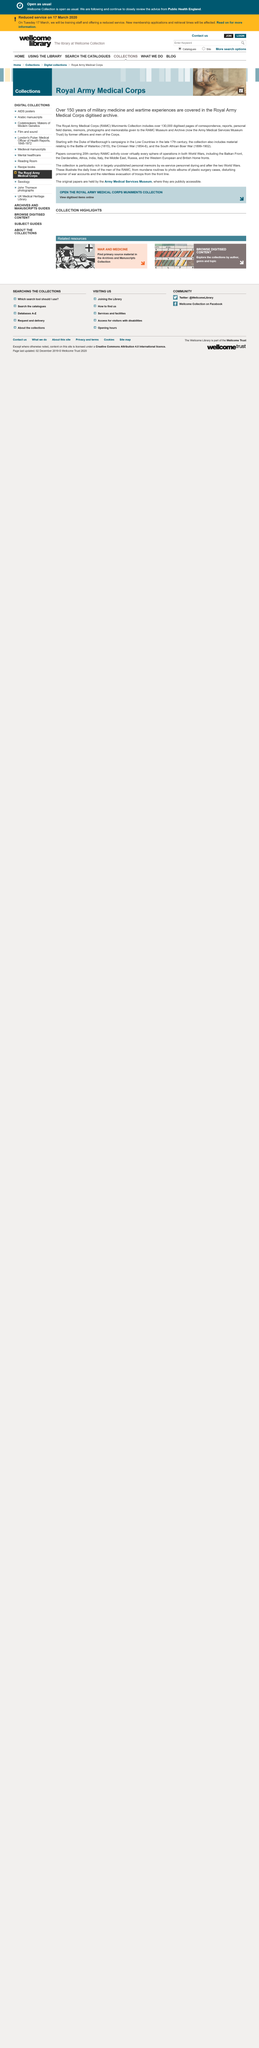Identify some key points in this picture. The Royal Army Medical Corps archives contain information on both World War I and World War II. The Royal Army Medical Corps has digitized over 130,000 pages, covering a significant amount of information. The Royal Army Medical Corps archives cover over 150 years, from the late 17th century to the modern 20th century wars, providing a comprehensive and extensive record of medical care and support within the military. 